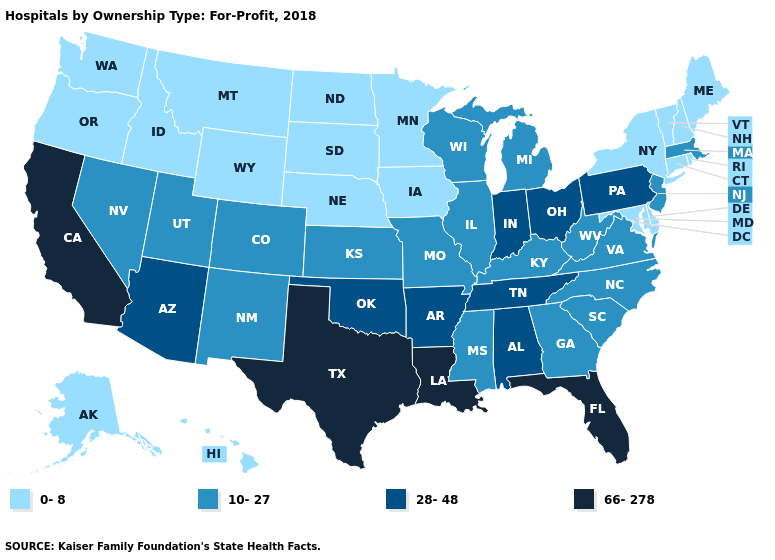What is the lowest value in the West?
Quick response, please. 0-8. Among the states that border New York , which have the highest value?
Answer briefly. Pennsylvania. Name the states that have a value in the range 0-8?
Short answer required. Alaska, Connecticut, Delaware, Hawaii, Idaho, Iowa, Maine, Maryland, Minnesota, Montana, Nebraska, New Hampshire, New York, North Dakota, Oregon, Rhode Island, South Dakota, Vermont, Washington, Wyoming. Does Kansas have the lowest value in the USA?
Write a very short answer. No. Among the states that border Connecticut , does Massachusetts have the lowest value?
Write a very short answer. No. Name the states that have a value in the range 0-8?
Be succinct. Alaska, Connecticut, Delaware, Hawaii, Idaho, Iowa, Maine, Maryland, Minnesota, Montana, Nebraska, New Hampshire, New York, North Dakota, Oregon, Rhode Island, South Dakota, Vermont, Washington, Wyoming. Does Maryland have the lowest value in the USA?
Give a very brief answer. Yes. Which states have the lowest value in the USA?
Keep it brief. Alaska, Connecticut, Delaware, Hawaii, Idaho, Iowa, Maine, Maryland, Minnesota, Montana, Nebraska, New Hampshire, New York, North Dakota, Oregon, Rhode Island, South Dakota, Vermont, Washington, Wyoming. What is the highest value in states that border Maine?
Answer briefly. 0-8. What is the value of New Jersey?
Answer briefly. 10-27. Which states have the lowest value in the Northeast?
Concise answer only. Connecticut, Maine, New Hampshire, New York, Rhode Island, Vermont. Name the states that have a value in the range 66-278?
Quick response, please. California, Florida, Louisiana, Texas. What is the lowest value in states that border New Hampshire?
Quick response, please. 0-8. Name the states that have a value in the range 0-8?
Short answer required. Alaska, Connecticut, Delaware, Hawaii, Idaho, Iowa, Maine, Maryland, Minnesota, Montana, Nebraska, New Hampshire, New York, North Dakota, Oregon, Rhode Island, South Dakota, Vermont, Washington, Wyoming. Name the states that have a value in the range 28-48?
Short answer required. Alabama, Arizona, Arkansas, Indiana, Ohio, Oklahoma, Pennsylvania, Tennessee. 